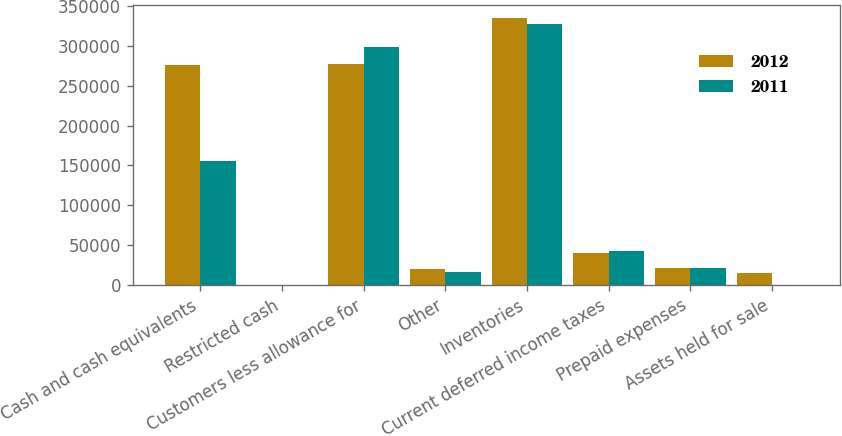Convert chart to OTSL. <chart><loc_0><loc_0><loc_500><loc_500><stacked_bar_chart><ecel><fcel>Cash and cash equivalents<fcel>Restricted cash<fcel>Customers less allowance for<fcel>Other<fcel>Inventories<fcel>Current deferred income taxes<fcel>Prepaid expenses<fcel>Assets held for sale<nl><fcel>2012<fcel>275478<fcel>0<fcel>277539<fcel>19441<fcel>335022<fcel>40696<fcel>21713<fcel>15083<nl><fcel>2011<fcel>155839<fcel>81<fcel>299166<fcel>15727<fcel>327657<fcel>43032<fcel>21598<fcel>0<nl></chart> 